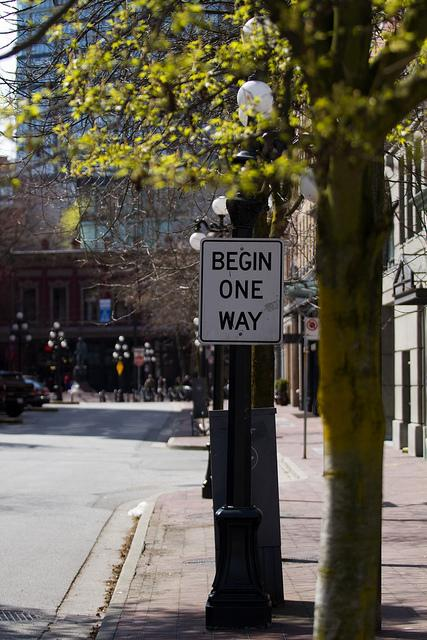What type of road is behind the person who took this picture? one way 